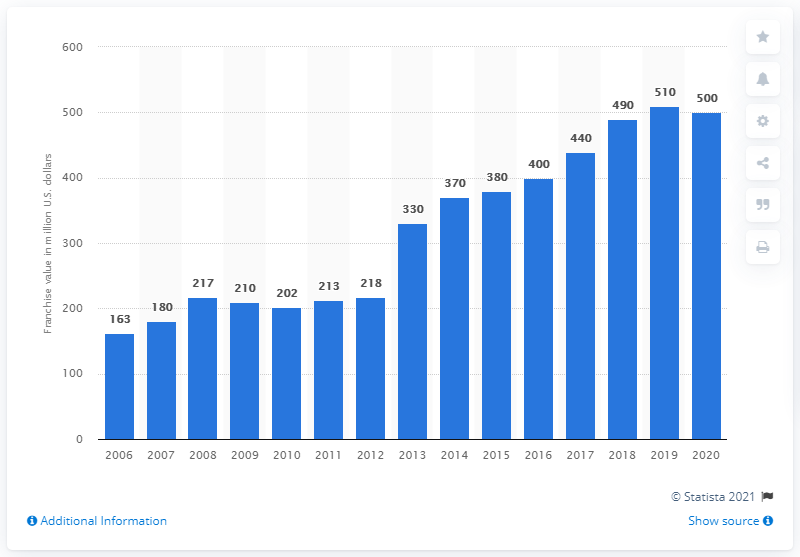Give some essential details in this illustration. The value of the Minnesota Wild franchise in dollars was approximately 500 in 2020. 